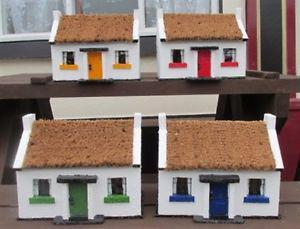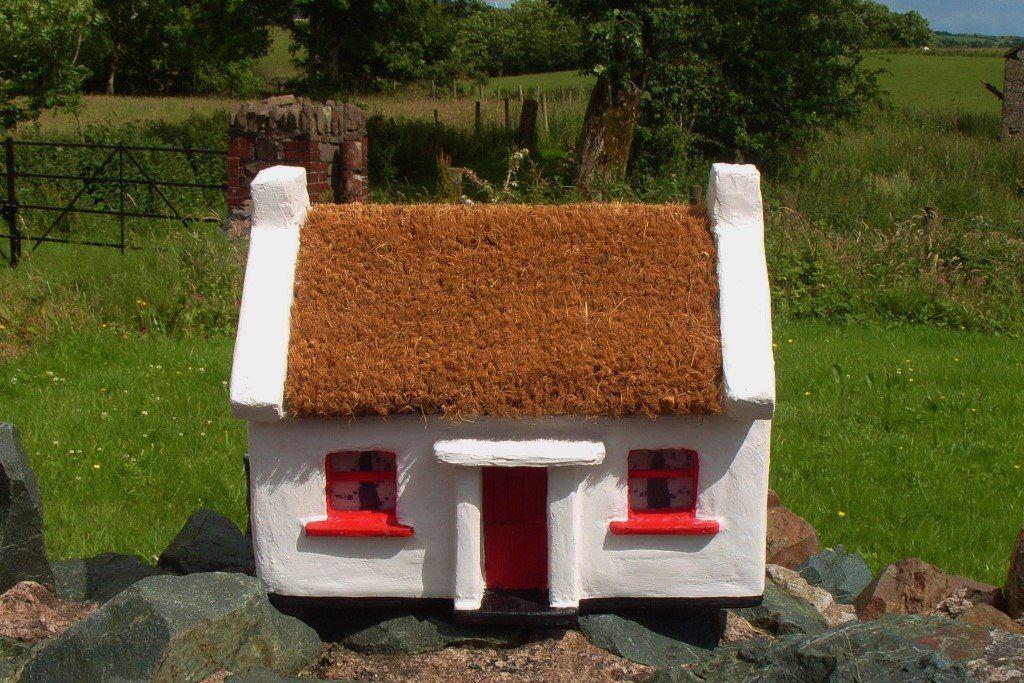The first image is the image on the left, the second image is the image on the right. Analyze the images presented: Is the assertion "At least one of the buildings has shutters around the windows." valid? Answer yes or no. No. The first image is the image on the left, the second image is the image on the right. Given the left and right images, does the statement "Each image shows one building with a thick textured roof and some flowers around it, and at least one of the roofs pictured curves around parts of the building." hold true? Answer yes or no. No. 